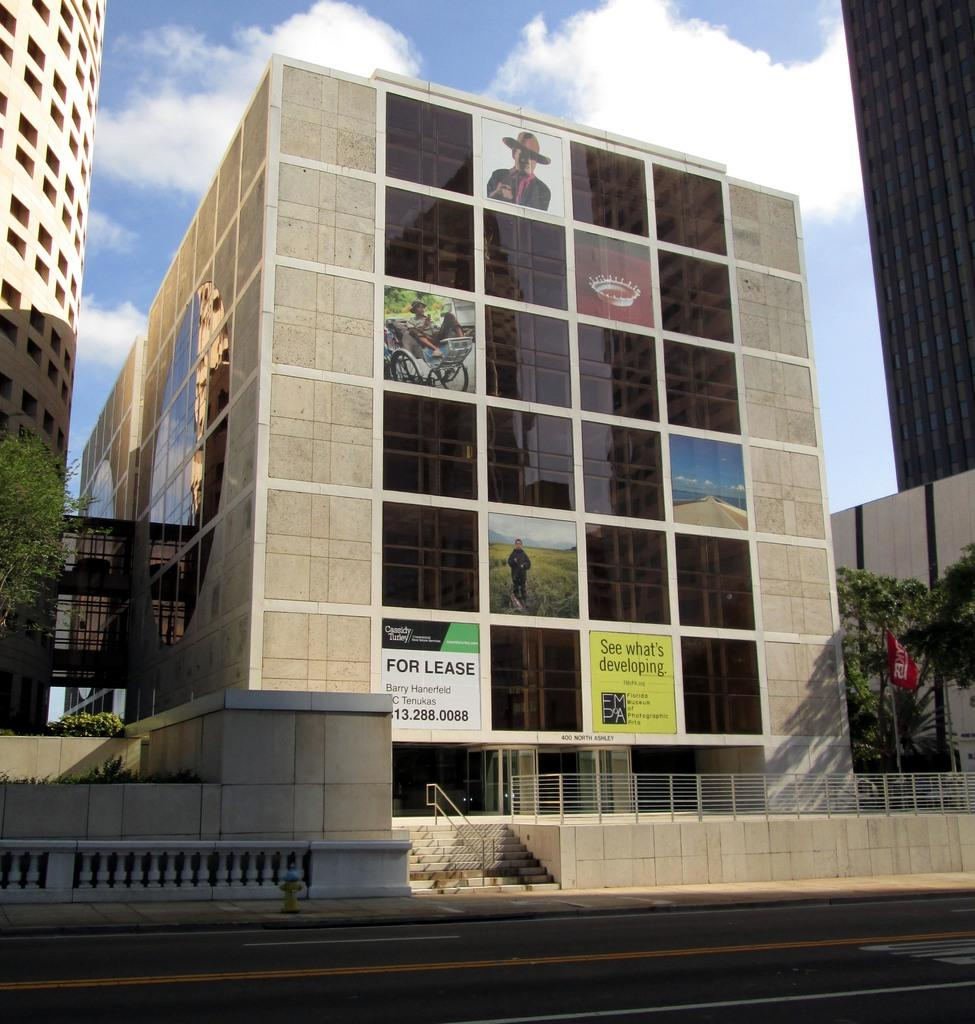What type of structures can be seen in the image? There are buildings in the image. What objects are present in the image that might be used for displaying information or advertisements? There are boards in the image. What objects can be seen in the image that might be used for drinking? There are glasses in the image. What type of natural vegetation is visible in the image? There are trees in the image. What architectural feature can be seen in the image? There is a fence in the image. What symbolic object is present in the image? There is a flag in the image. What part of the natural environment is visible in the background of the image? The sky is visible in the background of the image. What weather condition can be inferred from the image? There are clouds in the sky, suggesting a partly cloudy day. Where is the mailbox located in the image? There is no mailbox present in the image. What type of reward is being offered to the fish in the image? There are no fish or rewards present in the image. 